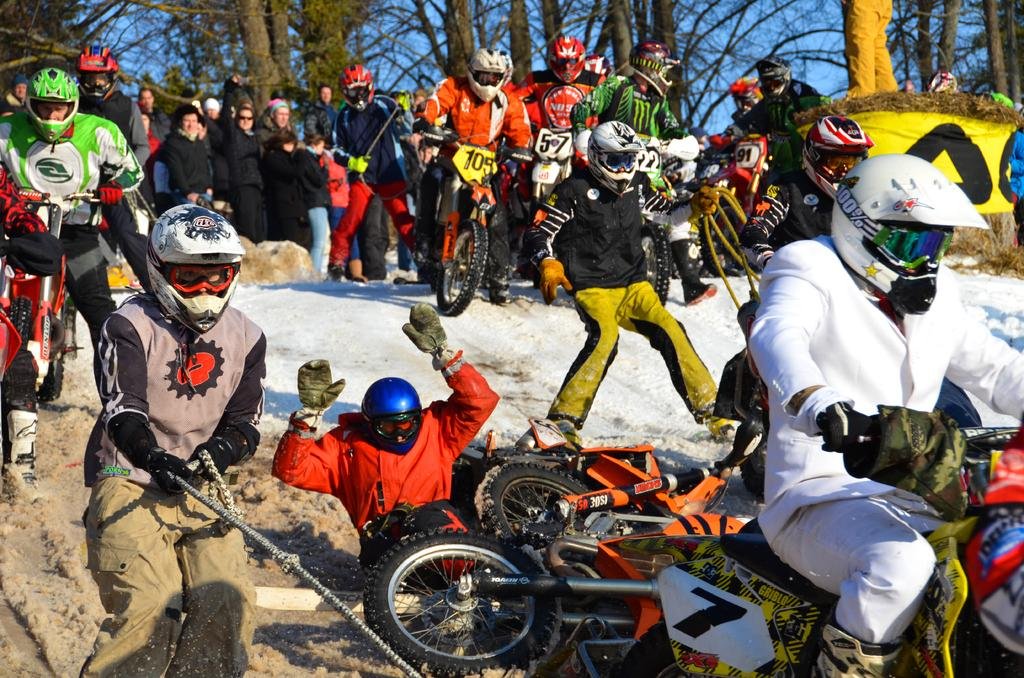What activity are the people in the image engaged in? The people in the image are preparing for a bike race. What can be seen in the background of the image? There are trees and the sky partially visible in the background of the image. What type of love can be seen between the trees in the image? There is no love present between the trees in the image, as trees do not have emotions or the ability to express love. 